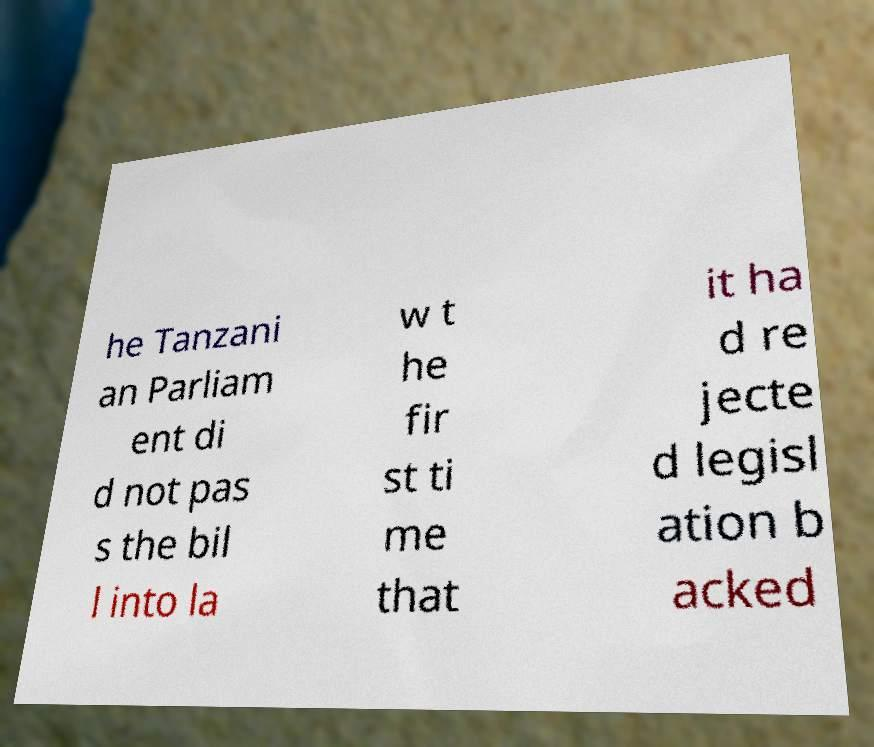Please read and relay the text visible in this image. What does it say? he Tanzani an Parliam ent di d not pas s the bil l into la w t he fir st ti me that it ha d re jecte d legisl ation b acked 